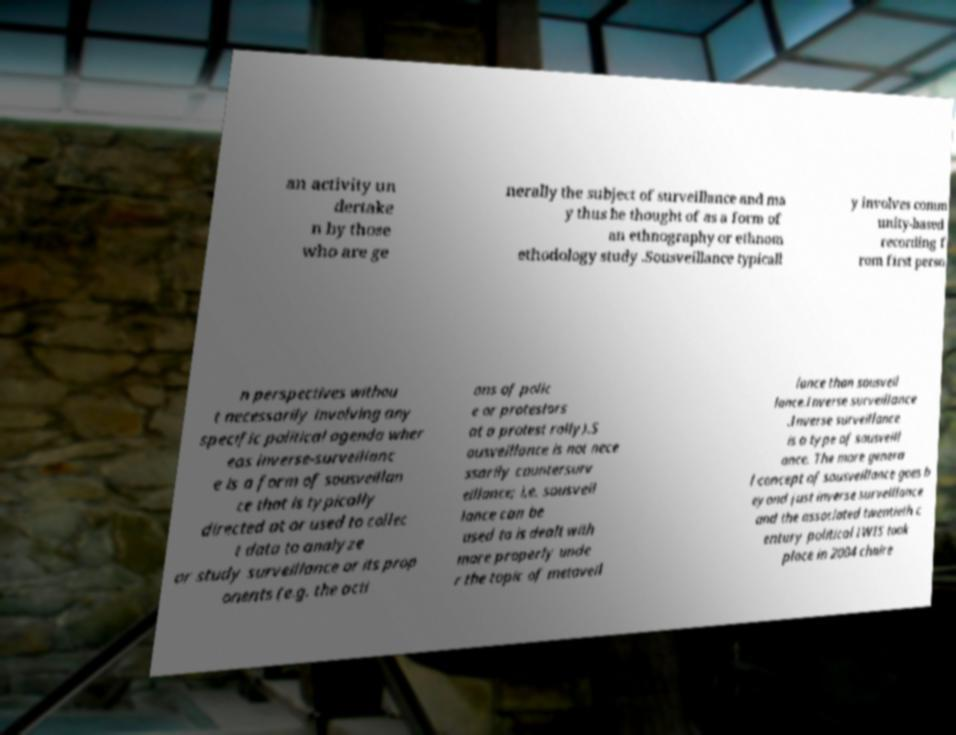I need the written content from this picture converted into text. Can you do that? an activity un dertake n by those who are ge nerally the subject of surveillance and ma y thus be thought of as a form of an ethnography or ethnom ethodology study .Sousveillance typicall y involves comm unity-based recording f rom first perso n perspectives withou t necessarily involving any specific political agenda wher eas inverse-surveillanc e is a form of sousveillan ce that is typically directed at or used to collec t data to analyze or study surveillance or its prop onents (e.g. the acti ons of polic e or protestors at a protest rally).S ousveillance is not nece ssarily countersurv eillance; i.e. sousveil lance can be used to is dealt with more properly unde r the topic of metaveil lance than sousveil lance.Inverse surveillance .Inverse surveillance is a type of sousveill ance. The more genera l concept of sousveillance goes b eyond just inverse surveillance and the associated twentieth c entury political IWIS took place in 2004 chaire 